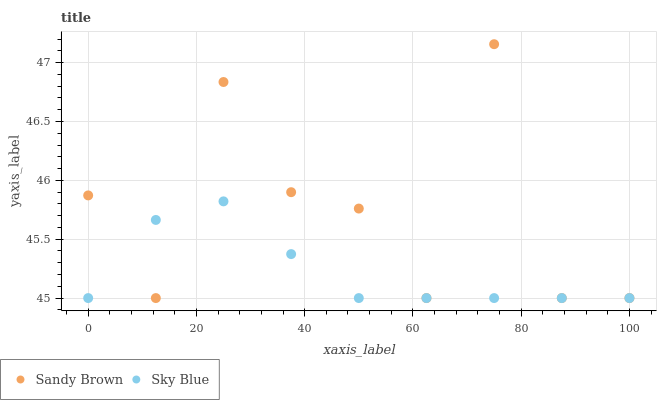Does Sky Blue have the minimum area under the curve?
Answer yes or no. Yes. Does Sandy Brown have the maximum area under the curve?
Answer yes or no. Yes. Does Sandy Brown have the minimum area under the curve?
Answer yes or no. No. Is Sky Blue the smoothest?
Answer yes or no. Yes. Is Sandy Brown the roughest?
Answer yes or no. Yes. Is Sandy Brown the smoothest?
Answer yes or no. No. Does Sky Blue have the lowest value?
Answer yes or no. Yes. Does Sandy Brown have the highest value?
Answer yes or no. Yes. Does Sky Blue intersect Sandy Brown?
Answer yes or no. Yes. Is Sky Blue less than Sandy Brown?
Answer yes or no. No. Is Sky Blue greater than Sandy Brown?
Answer yes or no. No. 